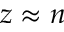<formula> <loc_0><loc_0><loc_500><loc_500>z \approx n</formula> 